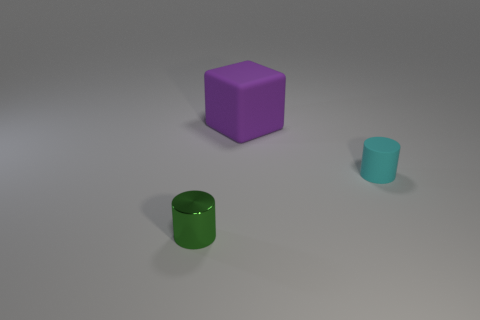What is the color of the small object that is made of the same material as the large purple thing?
Make the answer very short. Cyan. How many small cyan objects have the same material as the cyan cylinder?
Your answer should be compact. 0. Is the number of cyan matte things that are right of the cyan cylinder the same as the number of large rubber things that are to the left of the purple cube?
Give a very brief answer. Yes. There is a tiny green object; is it the same shape as the tiny object that is behind the shiny object?
Ensure brevity in your answer.  Yes. Are there any other things that have the same shape as the purple object?
Make the answer very short. No. Is the material of the large thing the same as the cylinder that is to the left of the small cyan cylinder?
Offer a terse response. No. What is the color of the small object that is in front of the cylinder that is behind the tiny cylinder in front of the small matte thing?
Keep it short and to the point. Green. Are there any other things that are the same size as the purple matte thing?
Your response must be concise. No. What is the color of the metal object?
Provide a short and direct response. Green. The matte object that is behind the tiny thing to the right of the matte object that is left of the tiny rubber cylinder is what shape?
Give a very brief answer. Cube. 